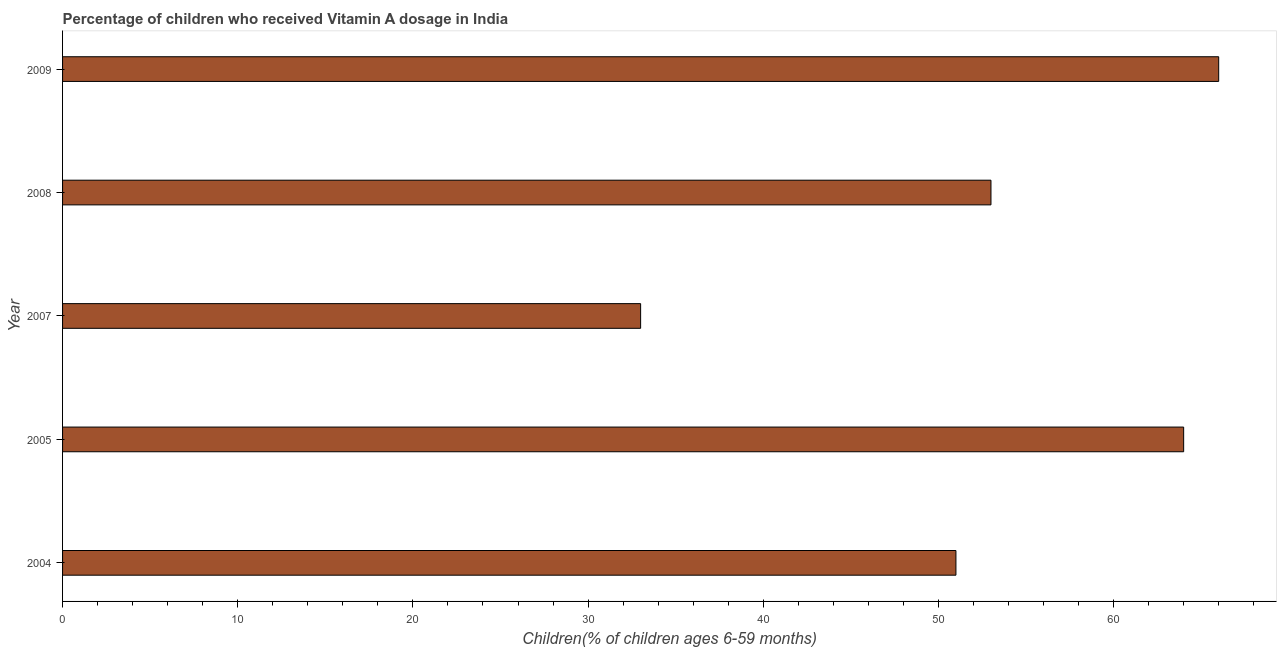Does the graph contain grids?
Offer a terse response. No. What is the title of the graph?
Provide a succinct answer. Percentage of children who received Vitamin A dosage in India. What is the label or title of the X-axis?
Offer a very short reply. Children(% of children ages 6-59 months). What is the label or title of the Y-axis?
Keep it short and to the point. Year. Across all years, what is the minimum vitamin a supplementation coverage rate?
Keep it short and to the point. 33. What is the sum of the vitamin a supplementation coverage rate?
Offer a very short reply. 267. What is the average vitamin a supplementation coverage rate per year?
Your answer should be compact. 53. What is the median vitamin a supplementation coverage rate?
Give a very brief answer. 53. What is the ratio of the vitamin a supplementation coverage rate in 2005 to that in 2007?
Keep it short and to the point. 1.94. What is the difference between the highest and the second highest vitamin a supplementation coverage rate?
Your answer should be very brief. 2. Is the sum of the vitamin a supplementation coverage rate in 2007 and 2008 greater than the maximum vitamin a supplementation coverage rate across all years?
Offer a very short reply. Yes. What is the difference between the highest and the lowest vitamin a supplementation coverage rate?
Your answer should be very brief. 33. In how many years, is the vitamin a supplementation coverage rate greater than the average vitamin a supplementation coverage rate taken over all years?
Your response must be concise. 2. Are all the bars in the graph horizontal?
Your answer should be compact. Yes. How many years are there in the graph?
Provide a short and direct response. 5. What is the difference between two consecutive major ticks on the X-axis?
Ensure brevity in your answer.  10. What is the Children(% of children ages 6-59 months) of 2005?
Your answer should be very brief. 64. What is the Children(% of children ages 6-59 months) in 2007?
Offer a very short reply. 33. What is the Children(% of children ages 6-59 months) in 2008?
Keep it short and to the point. 53. What is the difference between the Children(% of children ages 6-59 months) in 2004 and 2007?
Ensure brevity in your answer.  18. What is the difference between the Children(% of children ages 6-59 months) in 2004 and 2008?
Make the answer very short. -2. What is the difference between the Children(% of children ages 6-59 months) in 2004 and 2009?
Your response must be concise. -15. What is the difference between the Children(% of children ages 6-59 months) in 2005 and 2007?
Provide a short and direct response. 31. What is the difference between the Children(% of children ages 6-59 months) in 2005 and 2008?
Give a very brief answer. 11. What is the difference between the Children(% of children ages 6-59 months) in 2005 and 2009?
Make the answer very short. -2. What is the difference between the Children(% of children ages 6-59 months) in 2007 and 2008?
Your answer should be compact. -20. What is the difference between the Children(% of children ages 6-59 months) in 2007 and 2009?
Provide a succinct answer. -33. What is the difference between the Children(% of children ages 6-59 months) in 2008 and 2009?
Keep it short and to the point. -13. What is the ratio of the Children(% of children ages 6-59 months) in 2004 to that in 2005?
Offer a terse response. 0.8. What is the ratio of the Children(% of children ages 6-59 months) in 2004 to that in 2007?
Keep it short and to the point. 1.54. What is the ratio of the Children(% of children ages 6-59 months) in 2004 to that in 2009?
Your response must be concise. 0.77. What is the ratio of the Children(% of children ages 6-59 months) in 2005 to that in 2007?
Give a very brief answer. 1.94. What is the ratio of the Children(% of children ages 6-59 months) in 2005 to that in 2008?
Provide a succinct answer. 1.21. What is the ratio of the Children(% of children ages 6-59 months) in 2005 to that in 2009?
Give a very brief answer. 0.97. What is the ratio of the Children(% of children ages 6-59 months) in 2007 to that in 2008?
Your answer should be compact. 0.62. What is the ratio of the Children(% of children ages 6-59 months) in 2008 to that in 2009?
Ensure brevity in your answer.  0.8. 